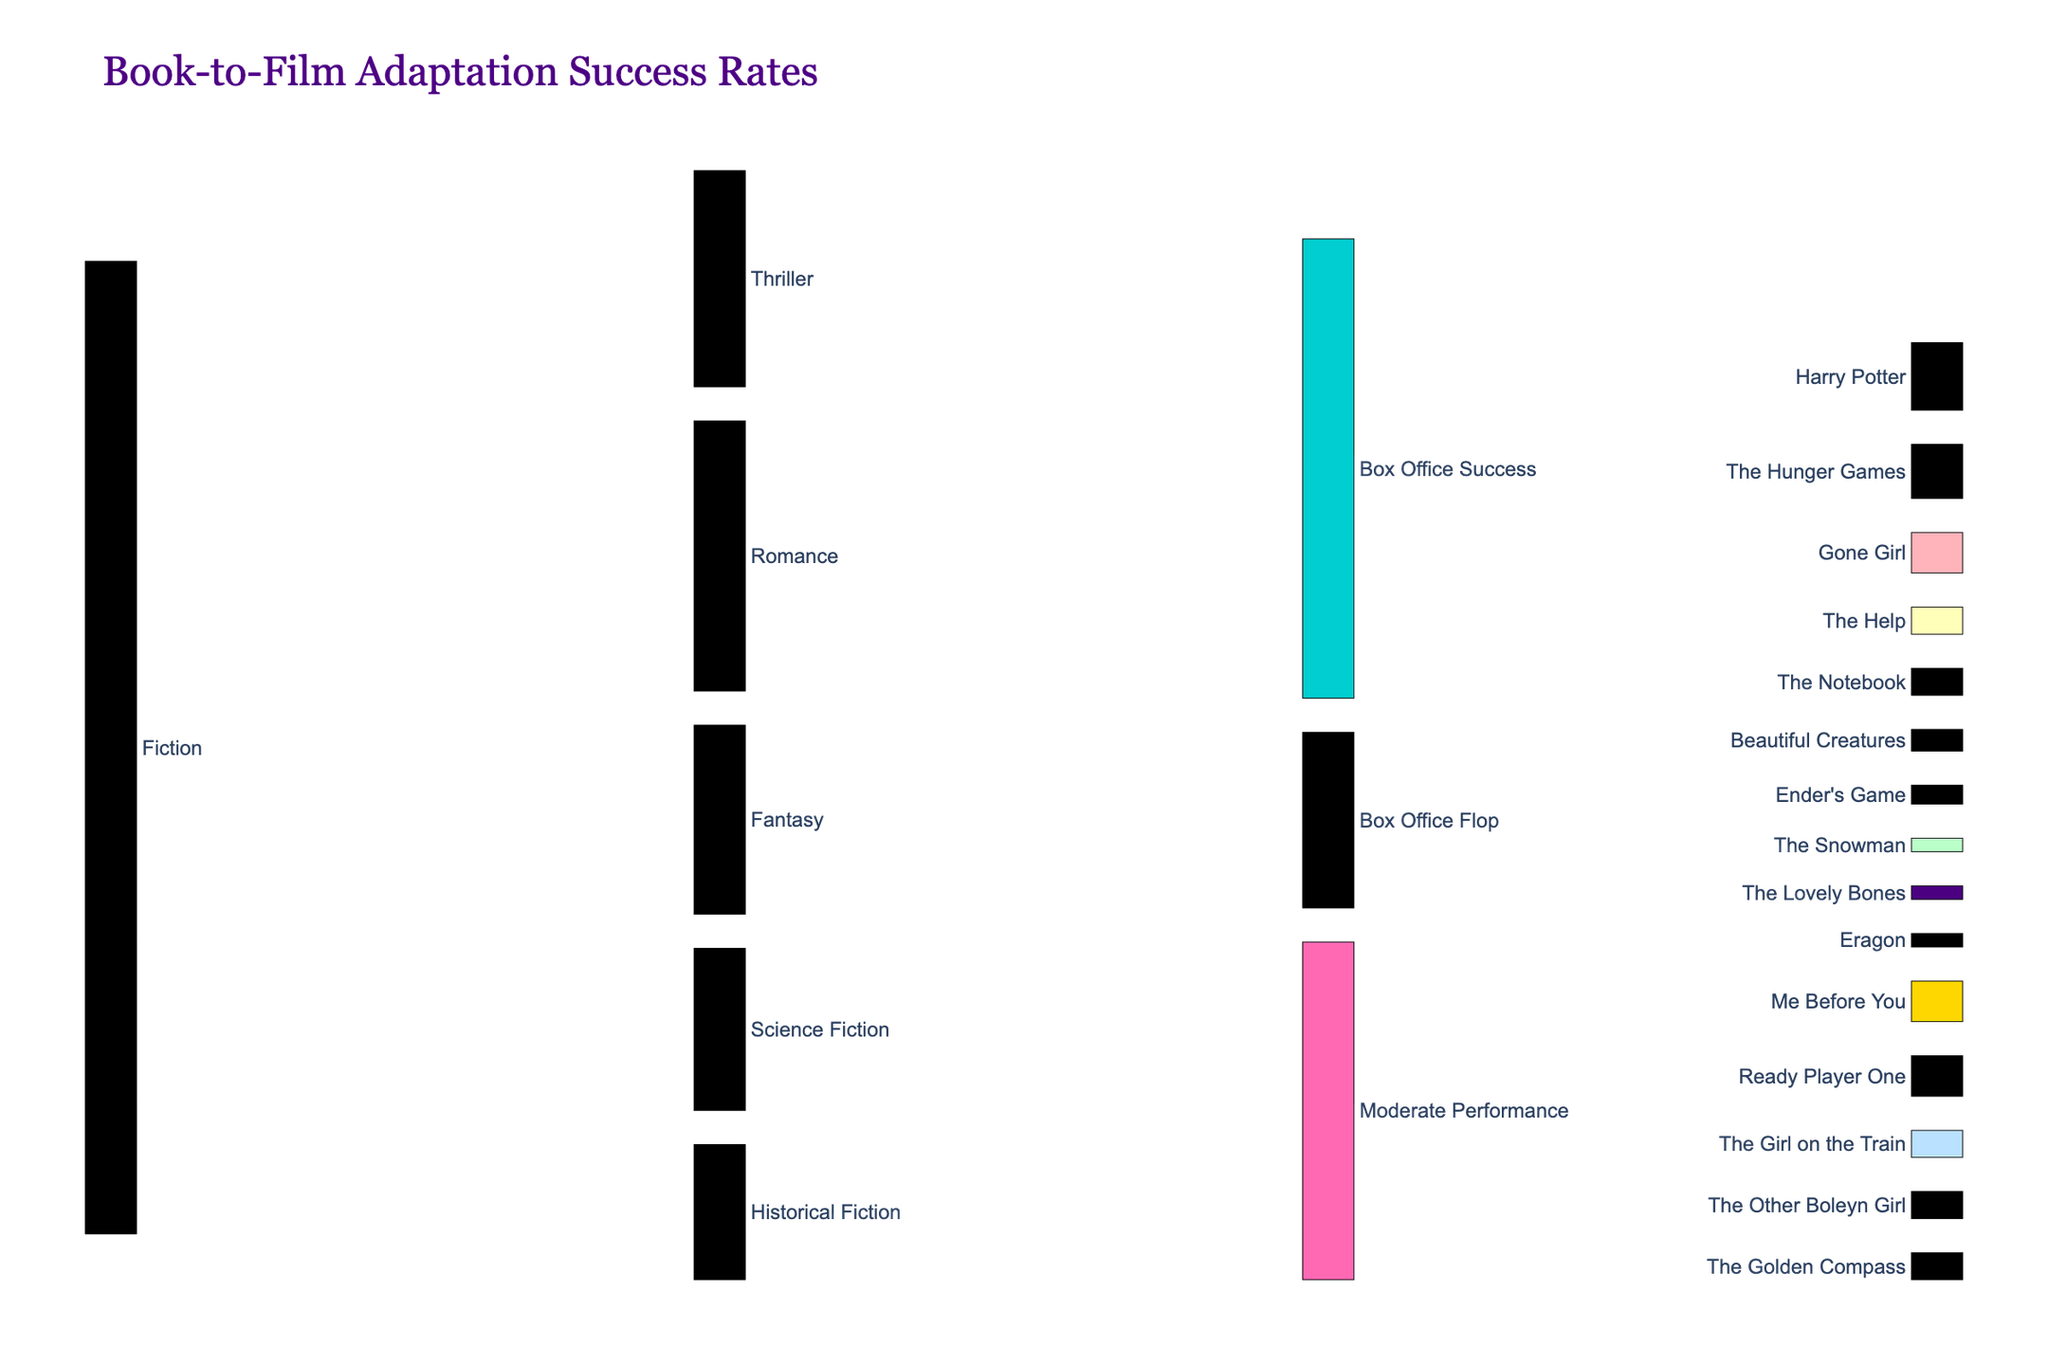What's the title of the Sankey diagram? The title is generally placed at the top of the diagram for easy identification. It provides an immediate context about the data being visualized.
Answer: Book-to-Film Adaptation Success Rates How many total adaptations are there in the Fantasy genre? By adding all the values leading from Fantasy to Box Office Success, Moderate Performance, and Box Office Flop, we get 35 + 25 + 10.
Answer: 70 Which genre has the highest number of book-to-film adaptations? To find this, compare the values for all genres (Fiction → sub-genres). Romance has 100 adaptations, Thriller has 80, Science Fiction has 60, Fantasy has 70, and Historical Fiction has 50. Romance has the highest.
Answer: Romance How many romance adaptations were box office successes? Look for the flow from Romance to Box Office Success and check its value.
Answer: 40 What percentage of Thriller adaptations resulted in box office flops? To find the percentage, divide the number of Flop films in Thriller by the total number of Thriller adaptations, then multiply by 100: (10/80) * 100.
Answer: 12.5% Which book has the highest box office success? Accompanying the flow from Box Office Success, find the movie with the highest specific value. Harry Potter has the highest value of 25.
Answer: Harry Potter How do you calculate the total number of Science Fiction adaptations that either moderately performed or flopped? Add the values leading from Science Fiction to Moderate Performance and Box Office Flop: 20 + 10.
Answer: 30 Which genre has the most balanced performance across Success, Moderate, and Flop categories? Check the distribution of values across the three categories for each genre. Historical Fiction has 20 for Success, 20 for Moderate Performance, and 10 for Flop, making it relatively balanced.
Answer: Historical Fiction What is the combined number of adaptations for Science Fiction and Historical Fiction genres? Add the total values for both genres: Science Fiction (60) + Historical Fiction (50).
Answer: 110 Compare the number of Science Fiction and Historical Fiction adaptations that became box office successes. Which genre has more? Check the flows from both genres to Box Office Success: Science Fiction → Box Office Success (30), Historical Fiction → Box Office Success (20). Science Fiction has more.
Answer: Science Fiction 